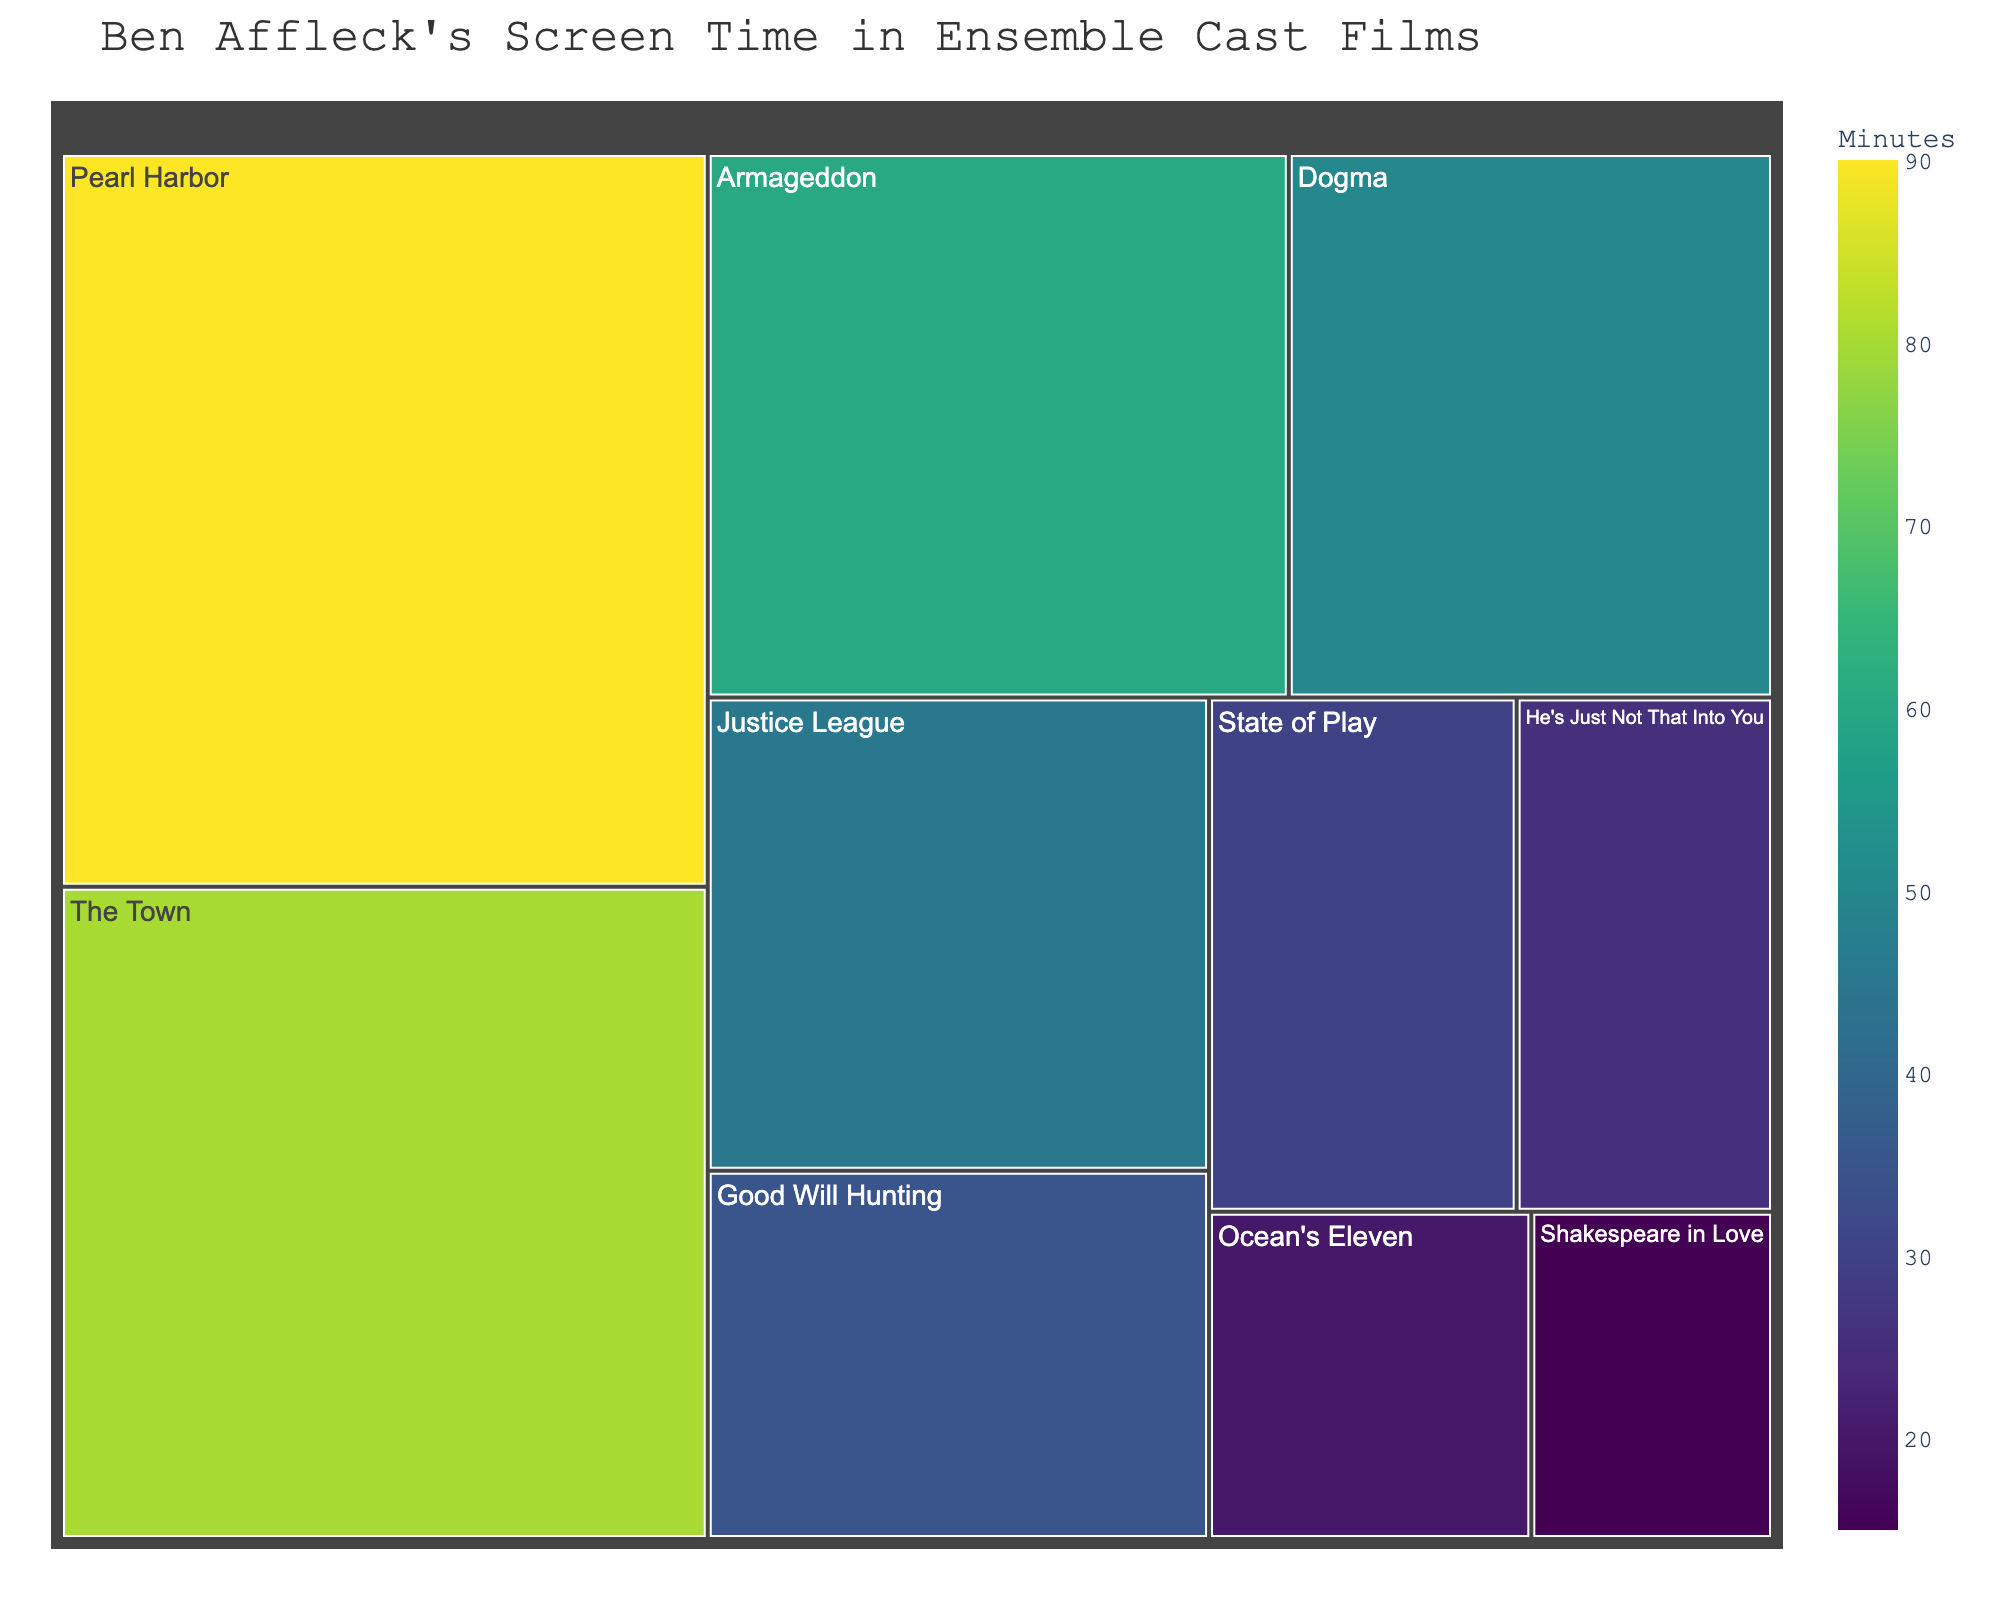What is the film title with the highest screen time for Ben Affleck? The title of the film occupies a larger section in the treemap with the highest value for screen time
Answer: Pearl Harbor Which film features Ben Affleck in the role of Batman and how much screen time does he have in that film? From the treemap, we can find "Justice League" and observe that the screen time is 45 minutes
Answer: Justice League, 45 minutes How much time does Ben Affleck spend on screen in "Dogma" compared to "He's Just Not That Into You"? According to the treemap, Ben Affleck's screen time in "Dogma" is 50 minutes, while in "He's Just Not That Into You," it is 25 minutes. So, 50 - 25 = 25
Answer: He spends 25 more minutes on screen in "Dogma" What is the total screen time for Ben Affleck across "Good Will Hunting," "Ocean's Eleven," and "Shakespeare in Love"? Sum up the screen times from the treemap: "Good Will Hunting" 35 minutes, "Ocean's Eleven" 20 minutes, and "Shakespeare in Love" 15 minutes. 35 + 20 + 15 = 70
Answer: 70 minutes Which film has the second-highest screen time for Ben Affleck, and what role does he play in that film? After examining the largest block, which is "Pearl Harbor" with 90 minutes, we look for the next largest block which is "The Town" with 80 minutes. He plays the role of Doug MacRay in "The Town"
Answer: The Town, Doug MacRay What is the average screen time for Ben Affleck's roles in these ensemble cast films? Sum the total screen time: 35 + 20 + 15 + 90 + 45 + 60 + 50 + 25 + 30 + 80 = 450 minutes. There are 10 films, so average is 450 / 10 = 45
Answer: 45 minutes Which film has exactly double the screen time compared to "He's Just Not That Into You"? Screen time for "He's Just Not That Into You" is 25 minutes. Look for a film with 50 minutes, which is "Dogma"
Answer: Dogma How does Ben Affleck's screen time in "Armageddon" compare to his screen time in "Justice League" and "State of Play" combined? Screen time in "Armageddon" is 60 minutes. Combined screen time in "Justice League" (45 minutes) and "State of Play" (30 minutes) is 45 + 30 = 75. 60 < 75
Answer: Less in Armageddon What is the color scale used in the treemap representation, and why is it significant? The color scale is 'Viridis,' which ranges from light to dark colors, helping to visualize screen time intensity and distribution clearly
Answer: Viridis 